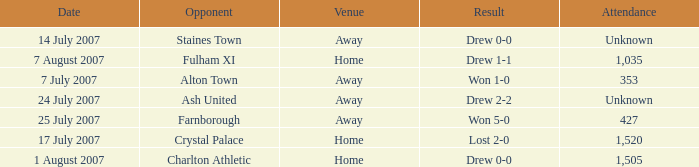Name the venue for staines town Away. 